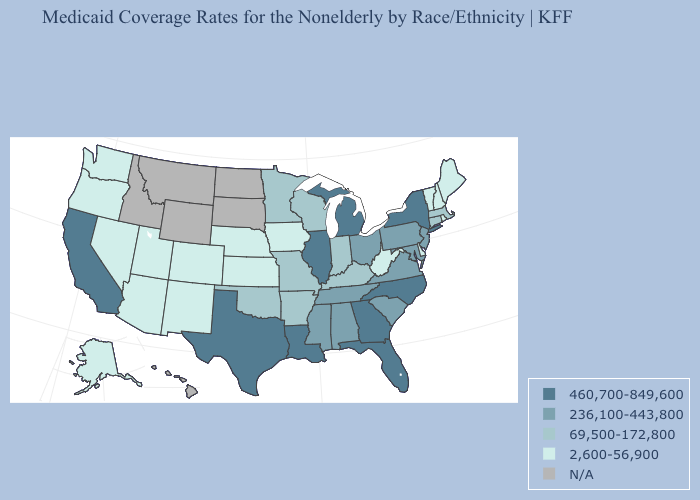Does New York have the highest value in the Northeast?
Give a very brief answer. Yes. Does Alaska have the highest value in the West?
Quick response, please. No. Name the states that have a value in the range 69,500-172,800?
Answer briefly. Arkansas, Connecticut, Indiana, Kentucky, Massachusetts, Minnesota, Missouri, Oklahoma, Wisconsin. Does Florida have the highest value in the South?
Write a very short answer. Yes. Is the legend a continuous bar?
Short answer required. No. Name the states that have a value in the range 460,700-849,600?
Keep it brief. California, Florida, Georgia, Illinois, Louisiana, Michigan, New York, North Carolina, Texas. How many symbols are there in the legend?
Concise answer only. 5. Does the map have missing data?
Concise answer only. Yes. Which states hav the highest value in the Northeast?
Concise answer only. New York. What is the highest value in states that border Kansas?
Give a very brief answer. 69,500-172,800. Name the states that have a value in the range N/A?
Keep it brief. Hawaii, Idaho, Montana, North Dakota, South Dakota, Wyoming. What is the value of New Hampshire?
Give a very brief answer. 2,600-56,900. What is the highest value in the USA?
Answer briefly. 460,700-849,600. 